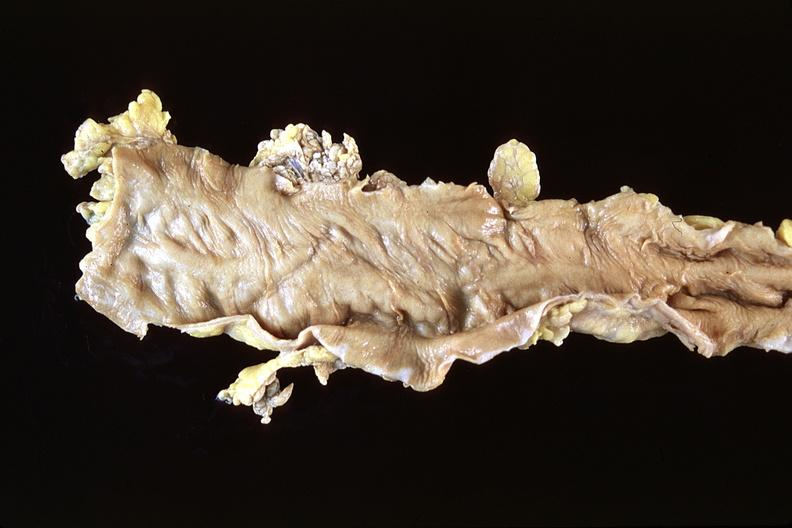s amyloid angiopathy r. endocrine present?
Answer the question using a single word or phrase. No 